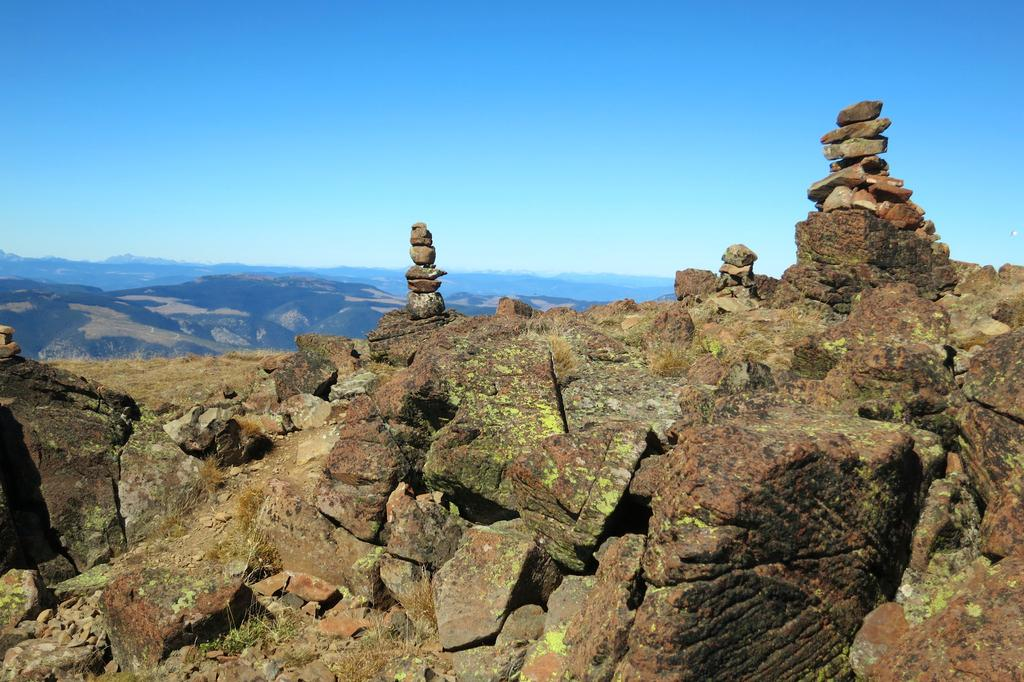What can be seen in the foreground of the picture? There are stones and grass in the foreground of the picture. What is visible in the background of the picture? There are hills in the background of the picture. How would you describe the weather in the image? The sky is sunny, suggesting a clear and pleasant day. Can you tell me how many people are participating in the protest in the image? There is no protest present in the image; it features stones, grass, hills, and a sunny sky. How many kisses can be seen between the stones in the image? There are no kisses depicted between the stones in the image. 